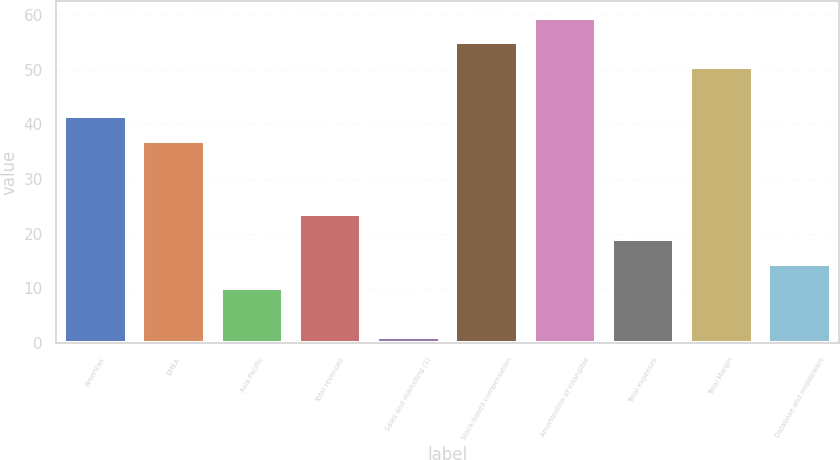Convert chart. <chart><loc_0><loc_0><loc_500><loc_500><bar_chart><fcel>Americas<fcel>EMEA<fcel>Asia Pacific<fcel>Total revenues<fcel>Sales and marketing (1)<fcel>Stock-based compensation<fcel>Amortization of intangible<fcel>Total expenses<fcel>Total Margin<fcel>Database and middleware<nl><fcel>41.5<fcel>37<fcel>10<fcel>23.5<fcel>1<fcel>55<fcel>59.5<fcel>19<fcel>50.5<fcel>14.5<nl></chart> 